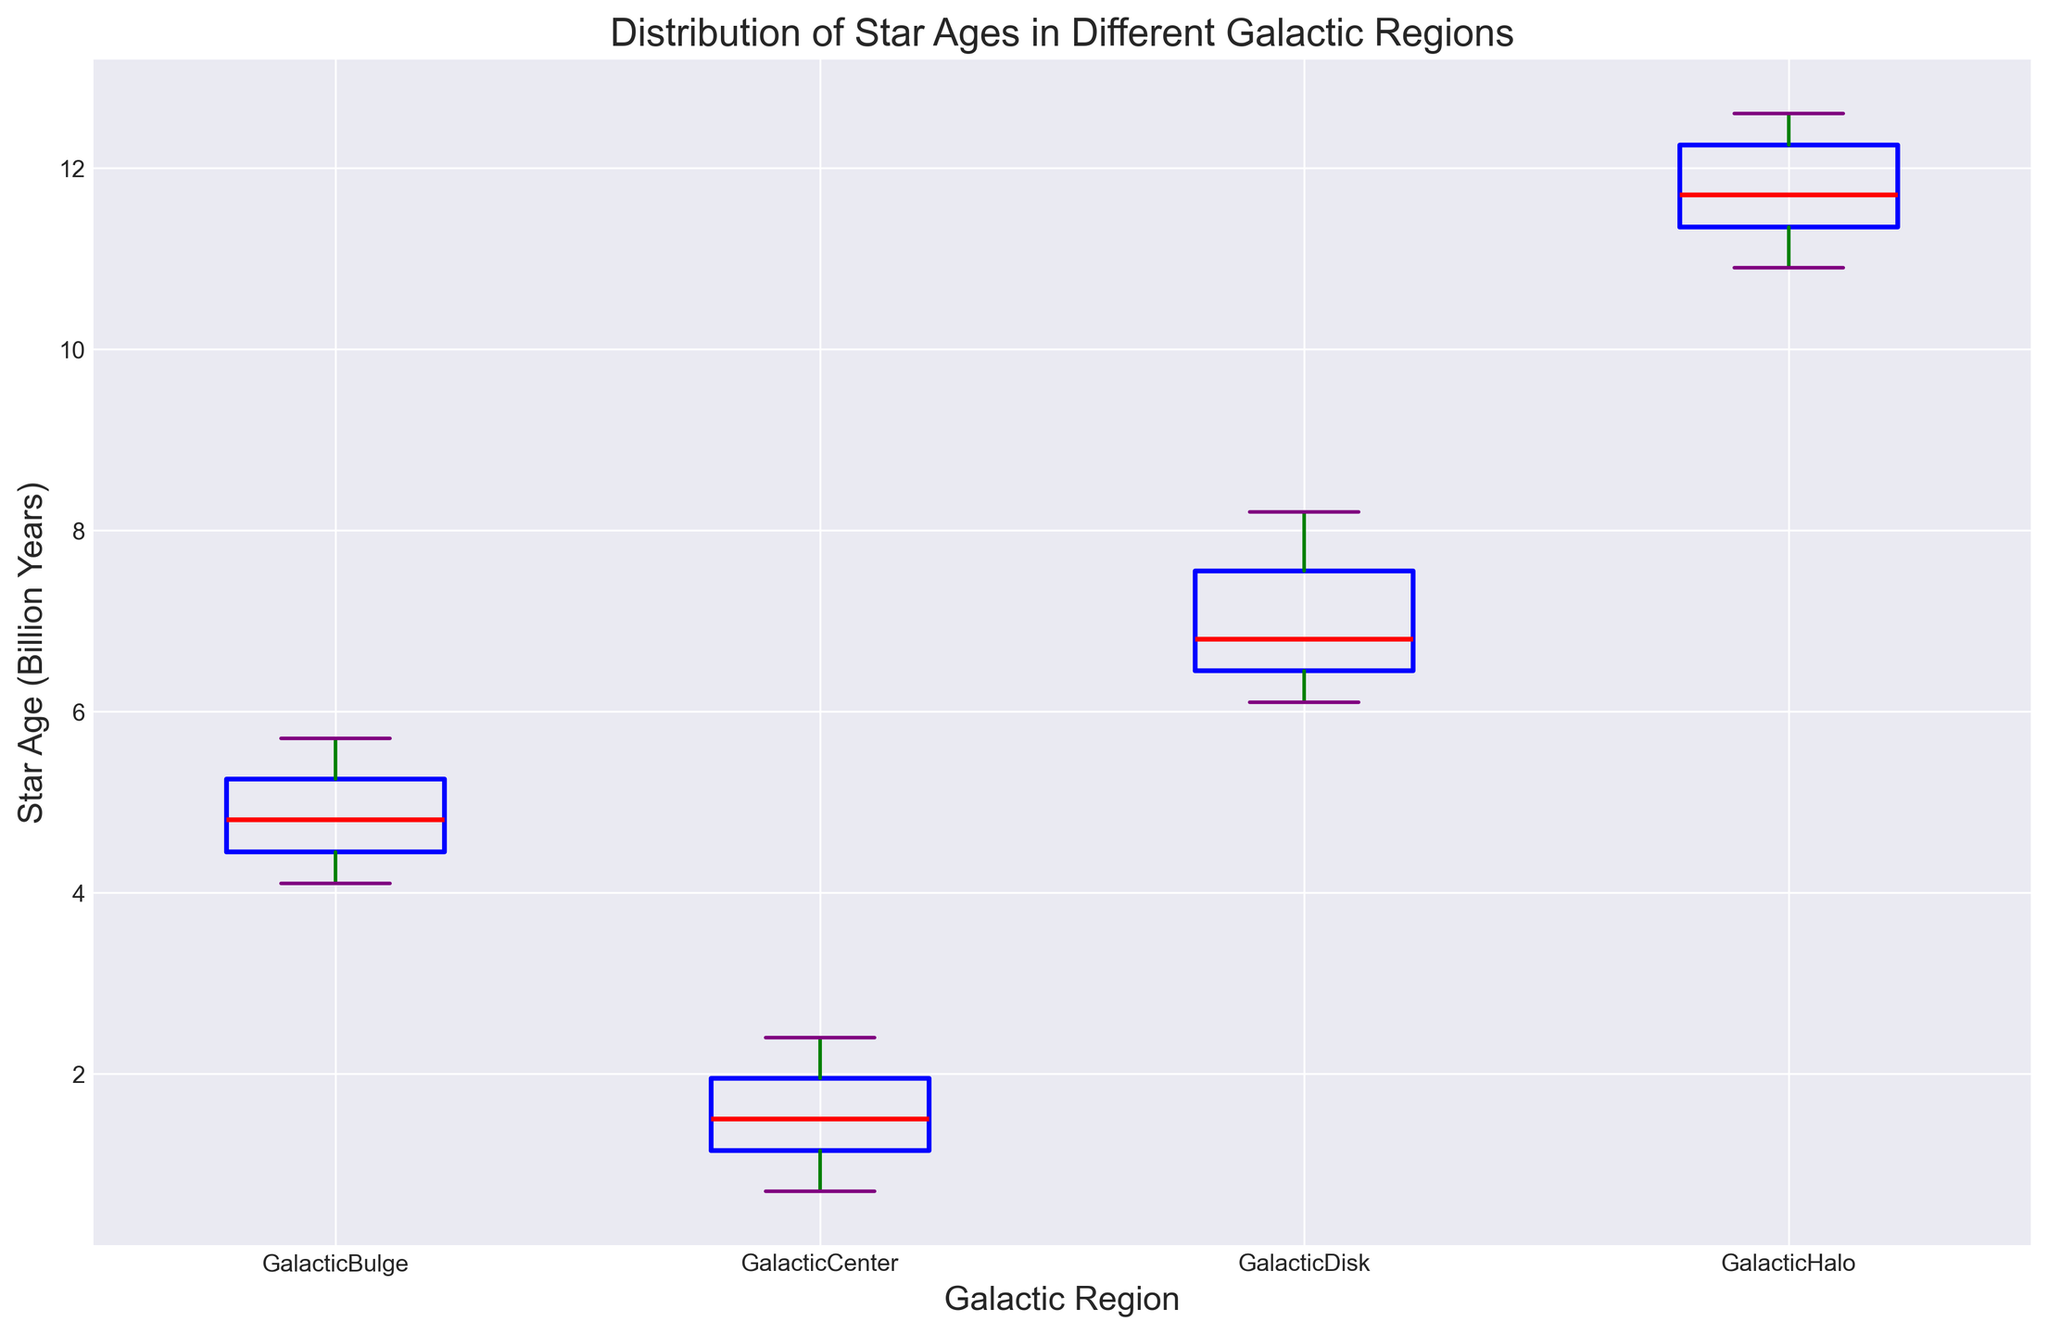What's the median star age in the Galactic Center? Identify the red line inside the box plot for the Galactic Center data. This line represents the median star age in that region.
Answer: 1.4 Which galactic region has the youngest stars? Compare the median lines (red) of all box plots. The median star age is lower for the Galactic Center compared to other regions.
Answer: Galactic Center Which galactic region displays the widest range of star ages? Compare the lengths of the whiskers (green) across all box plots. The Galactic Halo has the widest range.
Answer: Galactic Halo Which galactic region has the most tightly clustered star ages around the median? The shortest distance between the quartiles (blue box's top and bottom edges) indicates the most tightly clustered ages around the median. This is observed in the Galactic Center.
Answer: Galactic Center How do the ranges of star ages in the Galactic Disk and Galactic Bulge compare? Observe the whiskers' lengths of both regions; sum the whiskers' lengths to get the range. The Galactic Disk range is from 6.1 to 8.2 while the Galactic Bulge range is from 4.1 to 5.7. The Galactic Disk range is wider.
Answer: Galactic Disk What is the median star age difference between the Galactic Center and Galactic Halo? Subtract the median star age of the Galactic Center (1.4) from the median star age of the Galactic Halo (11.7). The difference is 11.7 - 1.4.
Answer: 10.3 billion years Identify any outliers in the Galactic Disk data. Look for data points marked outside the whiskers (orange circles) in the Galactic Disk box plot. There are no outliers; all points fall within the whiskers.
Answer: None What is the interquartile range (IQR) of star ages in the Galactic Bulge? Measure the length of the blue box for the Galactic Bulge box plot. IQR is Q3 - Q1, which corresponds to the top and bottom of the blue box. (5.3 - 4.3) = 1.0.
Answer: 1.0 billion years Which Galactic Region has the oldest median star age? The red line is at its highest point in the Galactic Halo box plot, indicating it has the oldest median star age among the regions.
Answer: Galactic Halo 